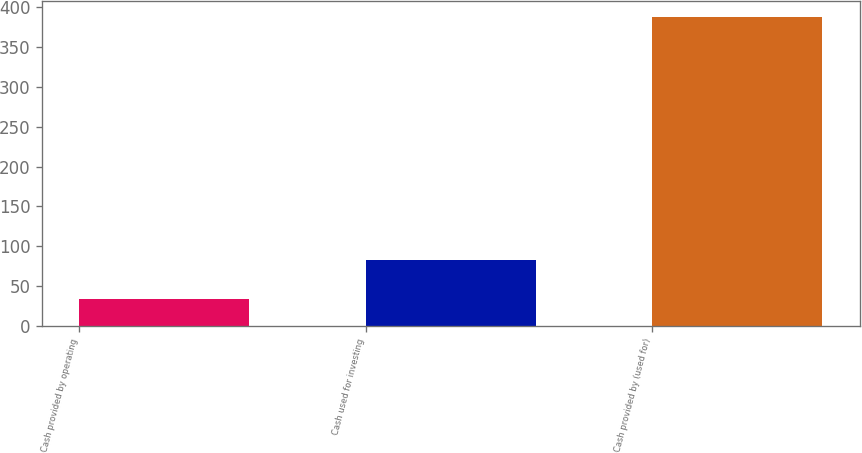<chart> <loc_0><loc_0><loc_500><loc_500><bar_chart><fcel>Cash provided by operating<fcel>Cash used for investing<fcel>Cash provided by (used for)<nl><fcel>34<fcel>83<fcel>388<nl></chart> 